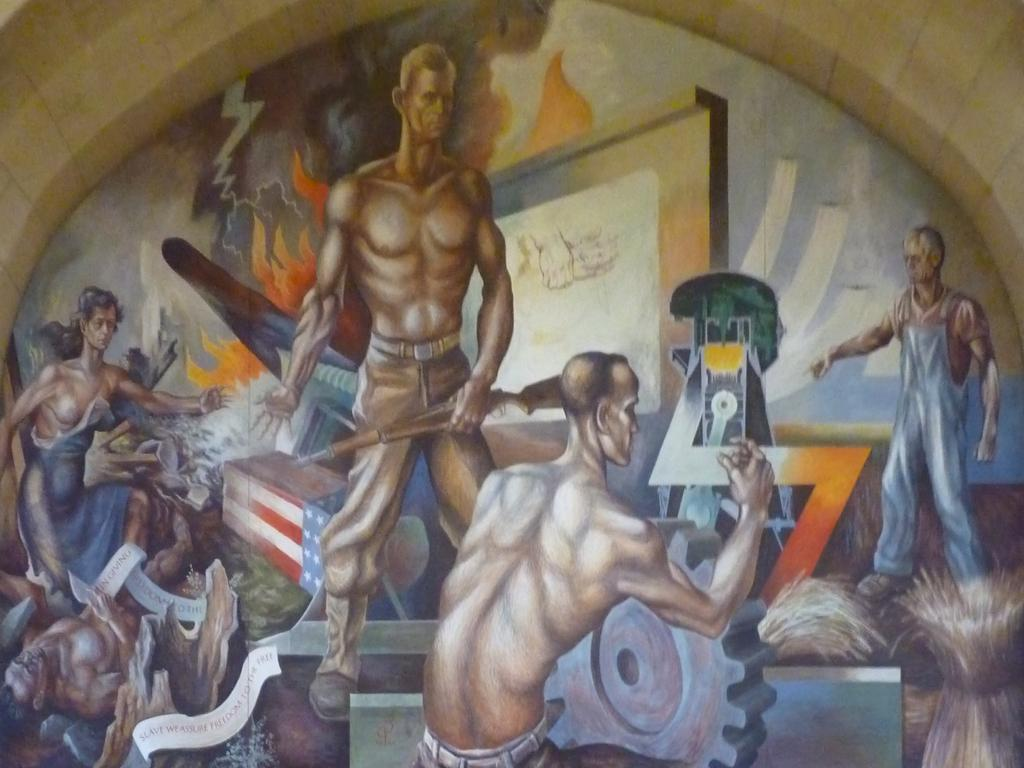What type of artwork is depicted in the image? The image is a painting. Can you describe the subjects in the painting? There are people present in the painting. What is one person doing in the painting? One person is holding a gun. What type of bean is being used as a prop in the painting? There is no bean present in the painting; it features people and one person holding a gun. 